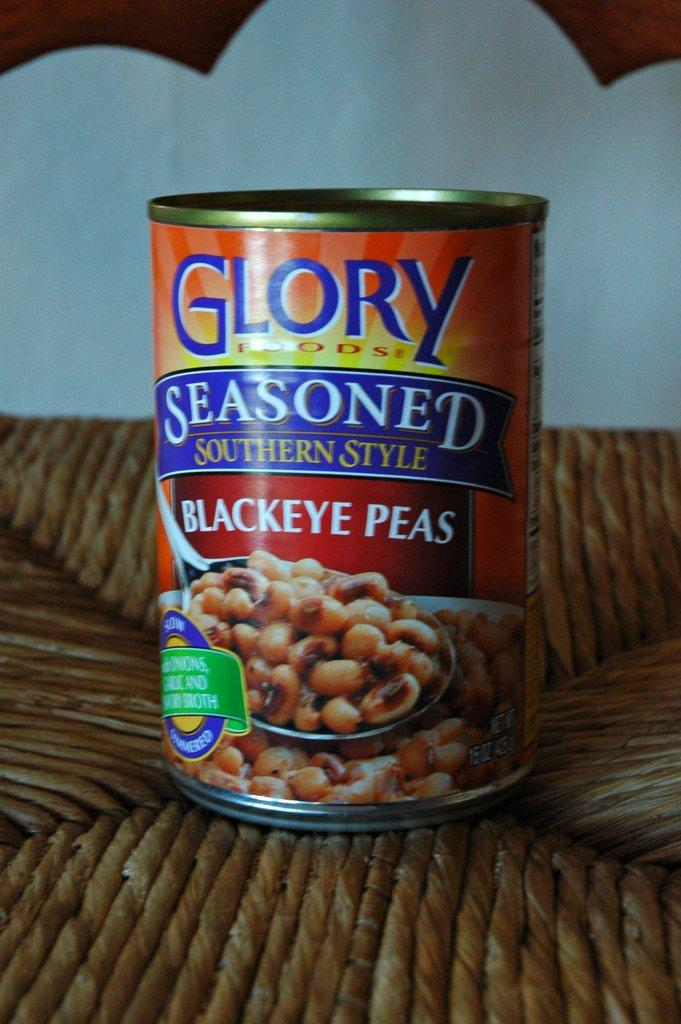What object can be seen in the image? There is a tin in the image. Where is the tin located? The tin is placed on a table. What is the condition of the tin in the image? The condition of the tin cannot be determined from the image alone, as there is no information about its condition provided. 